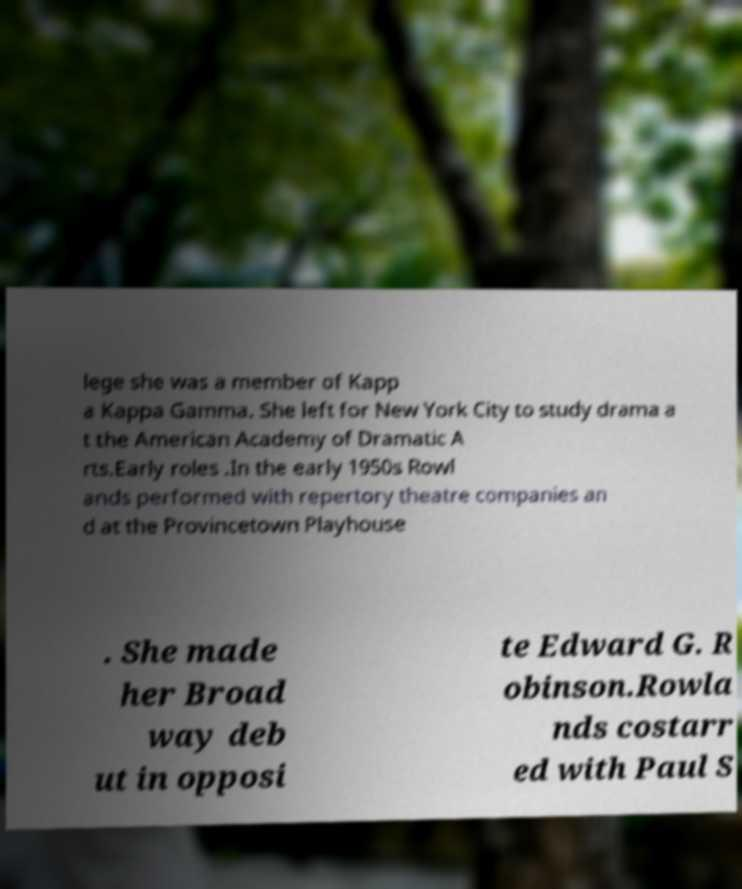Can you accurately transcribe the text from the provided image for me? lege she was a member of Kapp a Kappa Gamma. She left for New York City to study drama a t the American Academy of Dramatic A rts.Early roles .In the early 1950s Rowl ands performed with repertory theatre companies an d at the Provincetown Playhouse . She made her Broad way deb ut in opposi te Edward G. R obinson.Rowla nds costarr ed with Paul S 